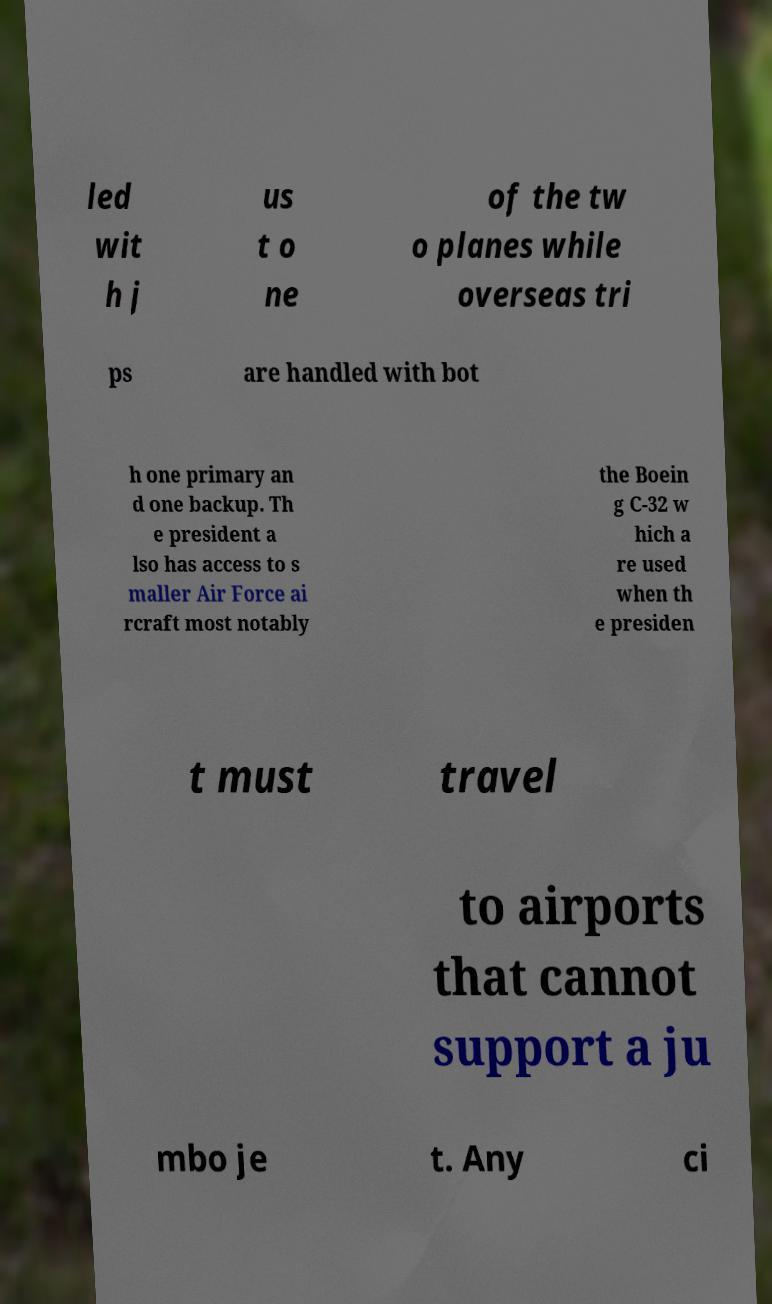There's text embedded in this image that I need extracted. Can you transcribe it verbatim? led wit h j us t o ne of the tw o planes while overseas tri ps are handled with bot h one primary an d one backup. Th e president a lso has access to s maller Air Force ai rcraft most notably the Boein g C-32 w hich a re used when th e presiden t must travel to airports that cannot support a ju mbo je t. Any ci 